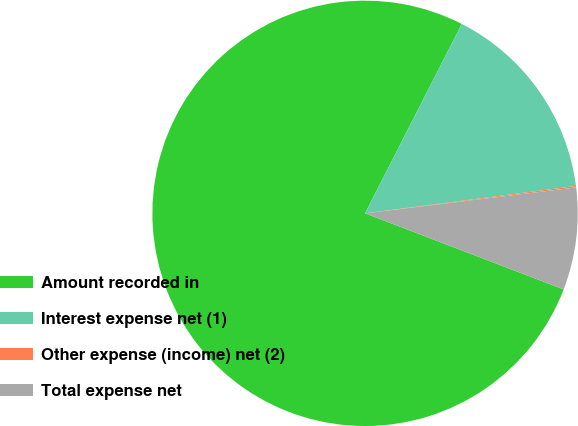<chart> <loc_0><loc_0><loc_500><loc_500><pie_chart><fcel>Amount recorded in<fcel>Interest expense net (1)<fcel>Other expense (income) net (2)<fcel>Total expense net<nl><fcel>76.7%<fcel>15.43%<fcel>0.11%<fcel>7.77%<nl></chart> 